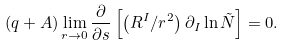<formula> <loc_0><loc_0><loc_500><loc_500>\left ( q + A \right ) \lim _ { r \rightarrow 0 } \frac { \partial } { \partial s } \left [ \left ( R ^ { I } / r ^ { 2 } \right ) \partial _ { I } \ln \tilde { N } \right ] = 0 .</formula> 